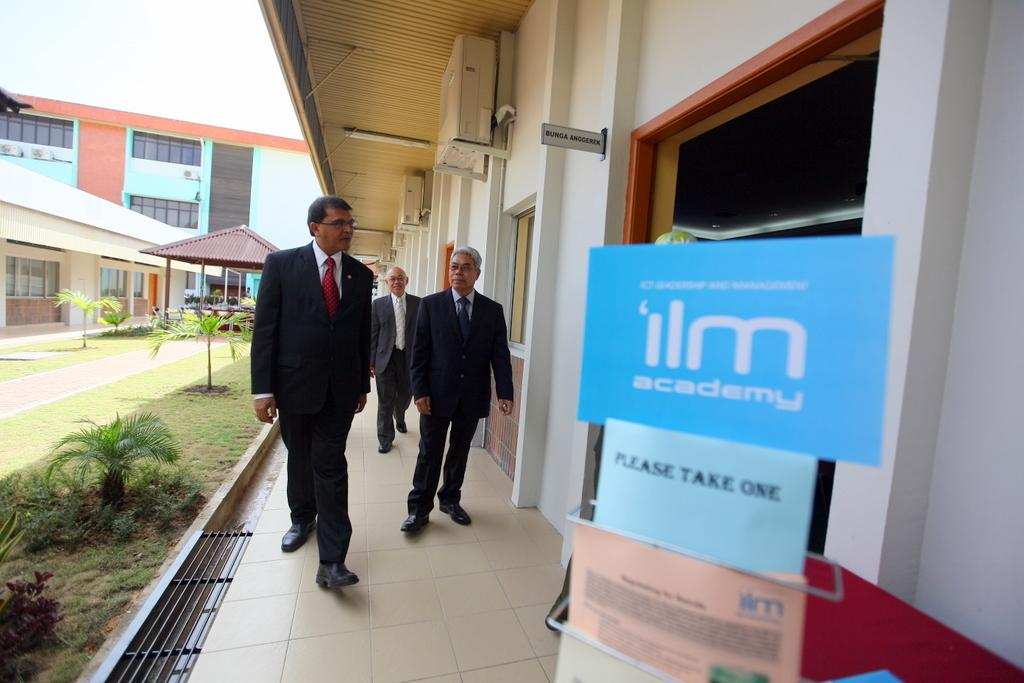<image>
Summarize the visual content of the image. Three men walking into a room with a stand that has cards that say "Please Take One". 